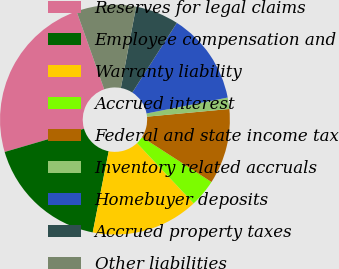Convert chart. <chart><loc_0><loc_0><loc_500><loc_500><pie_chart><fcel>Reserves for legal claims<fcel>Employee compensation and<fcel>Warranty liability<fcel>Accrued interest<fcel>Federal and state income tax<fcel>Inventory related accruals<fcel>Homebuyer deposits<fcel>Accrued property taxes<fcel>Other liabilities<nl><fcel>24.12%<fcel>17.37%<fcel>15.11%<fcel>3.86%<fcel>10.61%<fcel>1.6%<fcel>12.86%<fcel>6.11%<fcel>8.36%<nl></chart> 